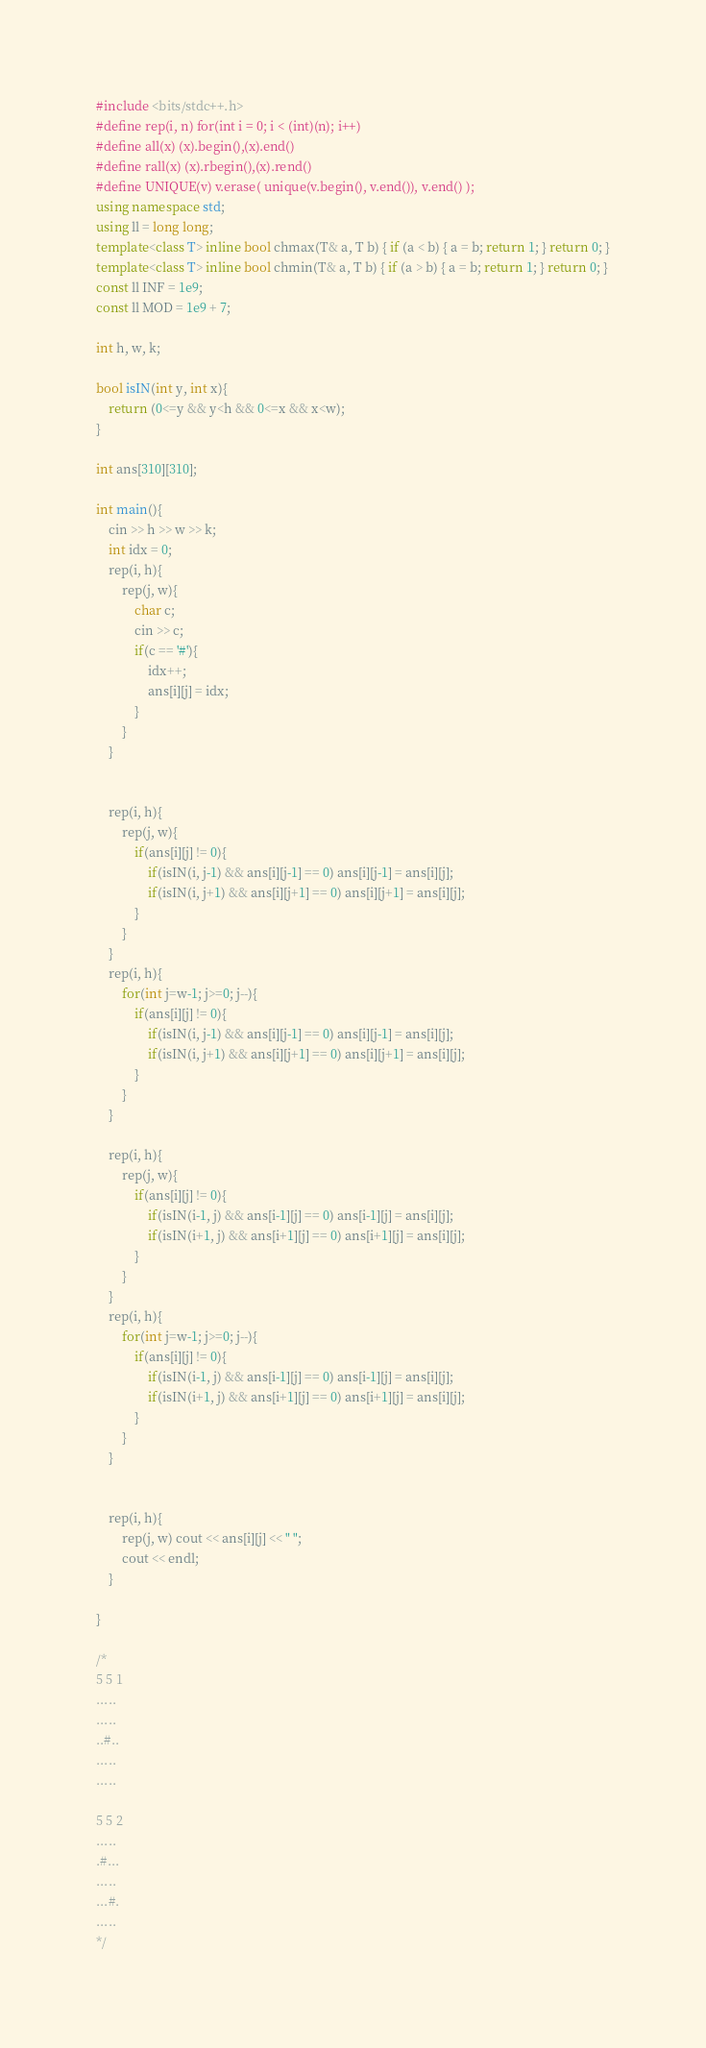<code> <loc_0><loc_0><loc_500><loc_500><_C++_>#include <bits/stdc++.h>
#define rep(i, n) for(int i = 0; i < (int)(n); i++)
#define all(x) (x).begin(),(x).end()
#define rall(x) (x).rbegin(),(x).rend()
#define UNIQUE(v) v.erase( unique(v.begin(), v.end()), v.end() );
using namespace std;
using ll = long long;
template<class T> inline bool chmax(T& a, T b) { if (a < b) { a = b; return 1; } return 0; }
template<class T> inline bool chmin(T& a, T b) { if (a > b) { a = b; return 1; } return 0; }
const ll INF = 1e9;
const ll MOD = 1e9 + 7;

int h, w, k;

bool isIN(int y, int x){
    return (0<=y && y<h && 0<=x && x<w);
}

int ans[310][310];

int main(){
    cin >> h >> w >> k;
    int idx = 0;
    rep(i, h){
        rep(j, w){
            char c;
            cin >> c;
            if(c == '#'){
                idx++;
                ans[i][j] = idx;
            }
        }
    }


    rep(i, h){
        rep(j, w){
            if(ans[i][j] != 0){
                if(isIN(i, j-1) && ans[i][j-1] == 0) ans[i][j-1] = ans[i][j];
                if(isIN(i, j+1) && ans[i][j+1] == 0) ans[i][j+1] = ans[i][j];
            }
        }
    }
    rep(i, h){
        for(int j=w-1; j>=0; j--){
            if(ans[i][j] != 0){
                if(isIN(i, j-1) && ans[i][j-1] == 0) ans[i][j-1] = ans[i][j];
                if(isIN(i, j+1) && ans[i][j+1] == 0) ans[i][j+1] = ans[i][j];
            }
        }
    }

    rep(i, h){
        rep(j, w){
            if(ans[i][j] != 0){
                if(isIN(i-1, j) && ans[i-1][j] == 0) ans[i-1][j] = ans[i][j];
                if(isIN(i+1, j) && ans[i+1][j] == 0) ans[i+1][j] = ans[i][j];
            }
        }
    }
    rep(i, h){
        for(int j=w-1; j>=0; j--){
            if(ans[i][j] != 0){
                if(isIN(i-1, j) && ans[i-1][j] == 0) ans[i-1][j] = ans[i][j];
                if(isIN(i+1, j) && ans[i+1][j] == 0) ans[i+1][j] = ans[i][j];
            }
        }
    }


    rep(i, h){
        rep(j, w) cout << ans[i][j] << " ";
        cout << endl;
    }

}

/*
5 5 1
.....
.....
..#..
.....
.....

5 5 2
.....
.#...
.....
...#.
.....
*/</code> 